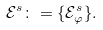<formula> <loc_0><loc_0><loc_500><loc_500>\mathcal { E } ^ { s } \colon = \{ \mathcal { E } _ { \varphi } ^ { s } \} .</formula> 